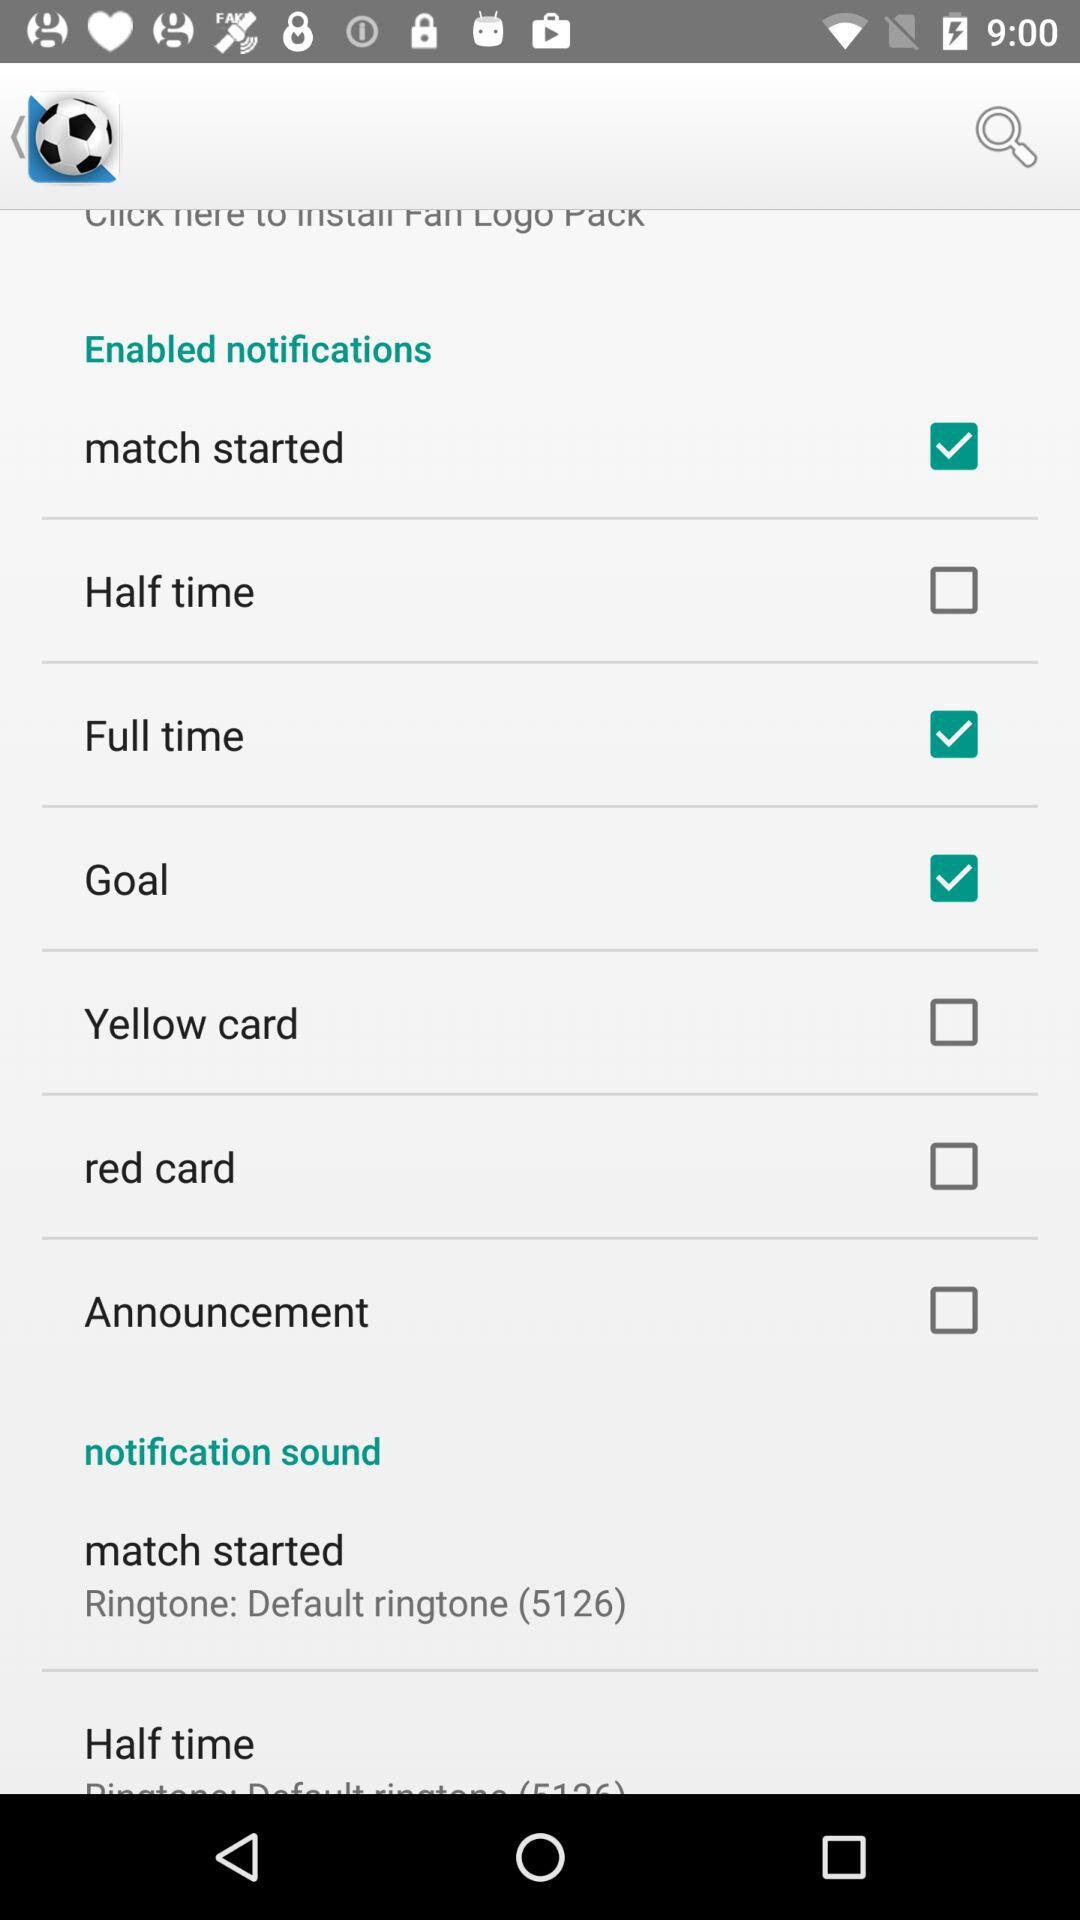Which notifications are disabled? The disabled notifications are "Half time", "Yellow card", "red card" and "Announcement". 